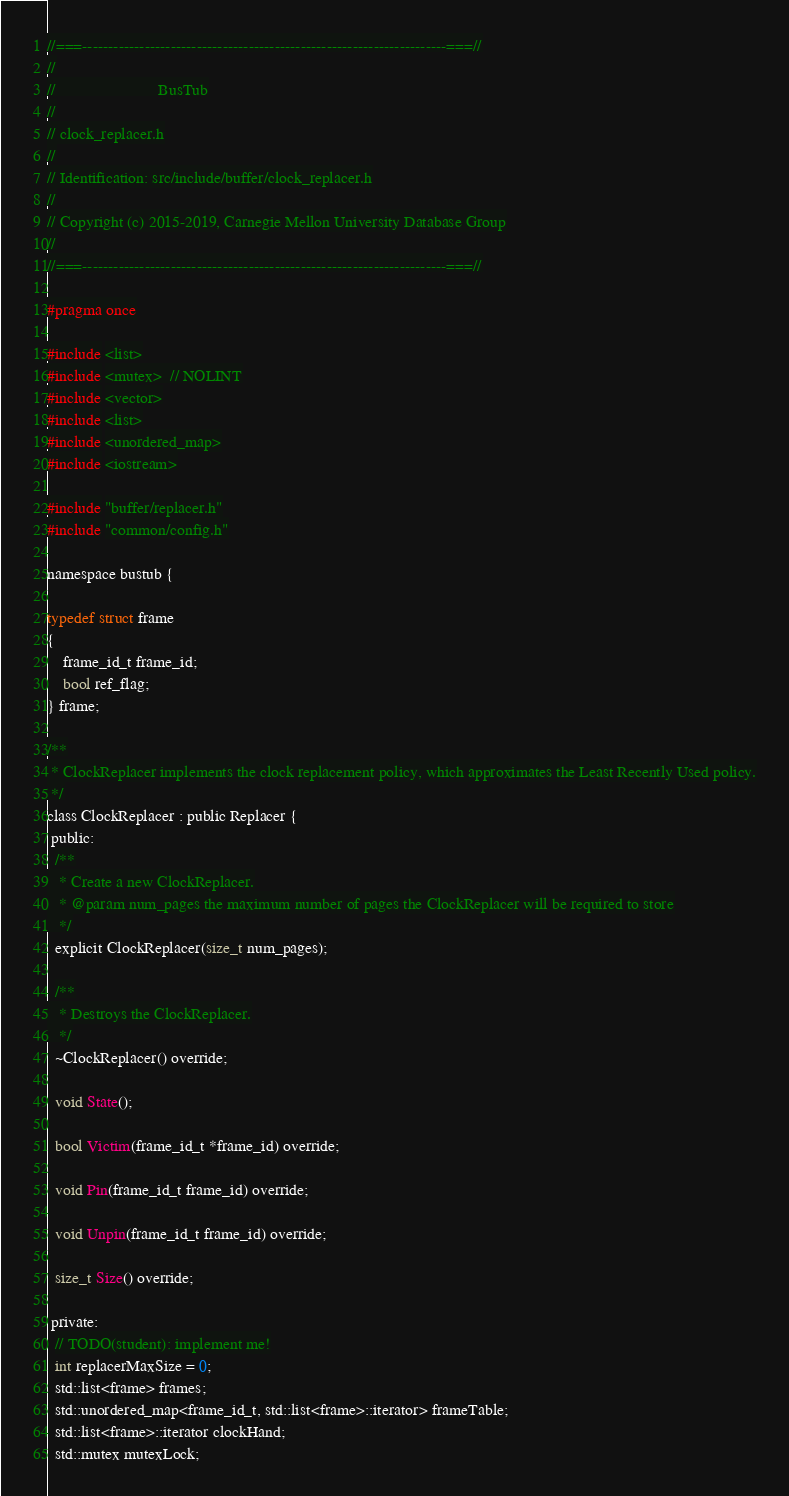Convert code to text. <code><loc_0><loc_0><loc_500><loc_500><_C_>//===----------------------------------------------------------------------===//
//
//                         BusTub
//
// clock_replacer.h
//
// Identification: src/include/buffer/clock_replacer.h
//
// Copyright (c) 2015-2019, Carnegie Mellon University Database Group
//
//===----------------------------------------------------------------------===//

#pragma once

#include <list>
#include <mutex>  // NOLINT
#include <vector>
#include <list>
#include <unordered_map>
#include <iostream>

#include "buffer/replacer.h"
#include "common/config.h"

namespace bustub {

typedef struct frame
{
    frame_id_t frame_id;
    bool ref_flag;
} frame;  

/**
 * ClockReplacer implements the clock replacement policy, which approximates the Least Recently Used policy.
 */
class ClockReplacer : public Replacer {
 public:
  /**
   * Create a new ClockReplacer.
   * @param num_pages the maximum number of pages the ClockReplacer will be required to store
   */
  explicit ClockReplacer(size_t num_pages);

  /**
   * Destroys the ClockReplacer.
   */
  ~ClockReplacer() override;

  void State();

  bool Victim(frame_id_t *frame_id) override;

  void Pin(frame_id_t frame_id) override;

  void Unpin(frame_id_t frame_id) override;

  size_t Size() override;

 private:
  // TODO(student): implement me!
  int replacerMaxSize = 0;
  std::list<frame> frames;
  std::unordered_map<frame_id_t, std::list<frame>::iterator> frameTable;
  std::list<frame>::iterator clockHand;
  std::mutex mutexLock;</code> 